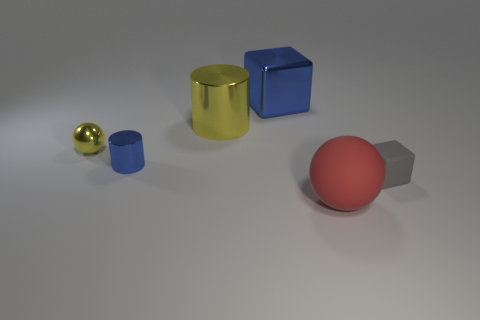What shape is the yellow metal thing that is the same size as the red matte thing? cylinder 